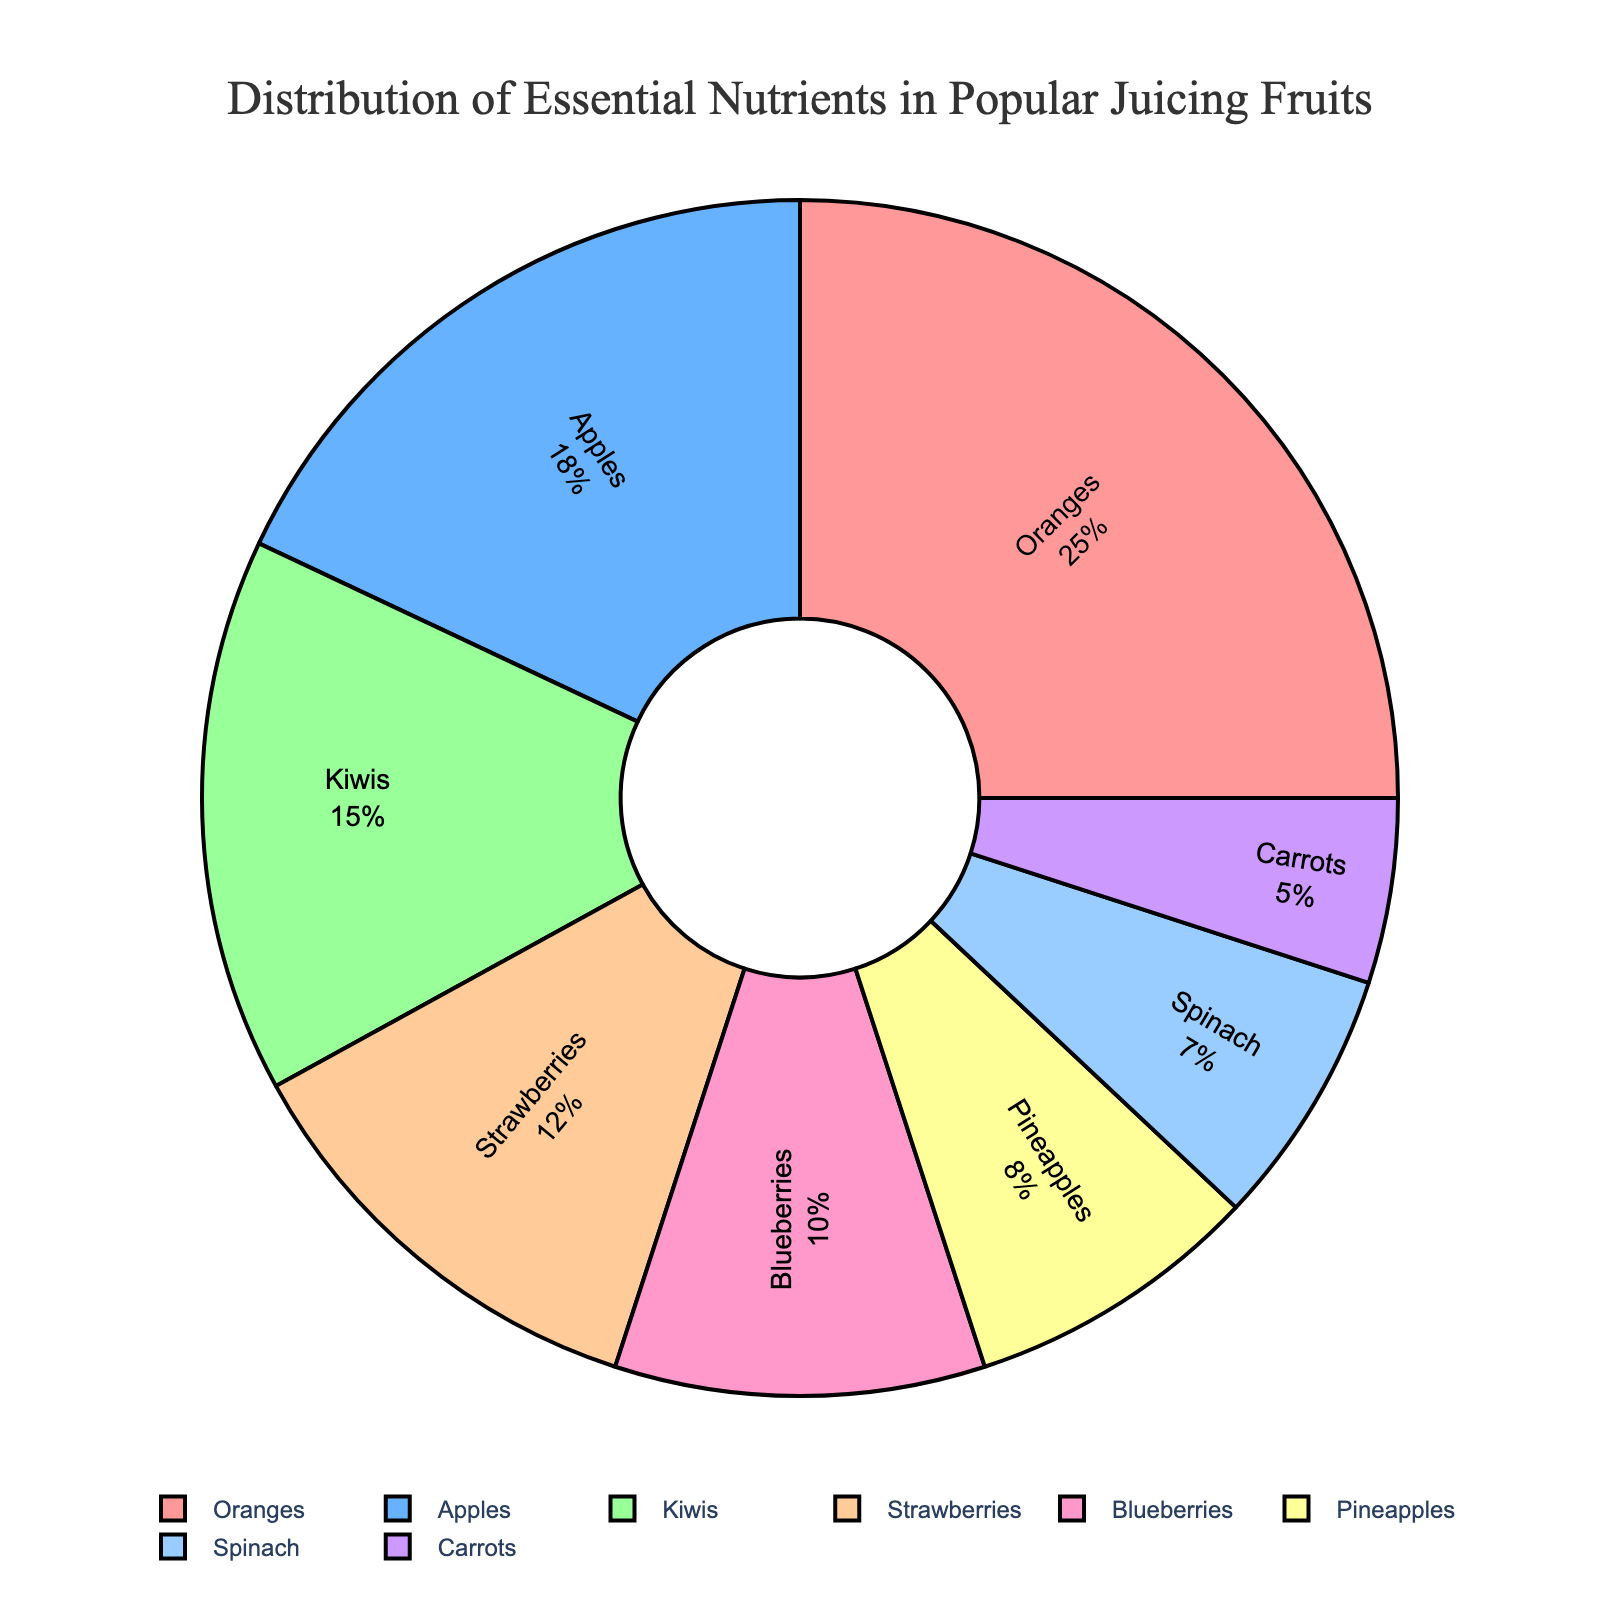What is the most nutrient-rich fruit for juicing? The pie chart shows that oranges have the largest percentage of essential nutrients at 25%.
Answer: Oranges Which fruit contributes the least to the essential nutrient distribution in juicing? Carrots have the smallest segment in the pie chart, indicating they contribute only 5% to the essential nutrient distribution.
Answer: Carrots How does the nutrient percentage of strawberries compare to that of kiwis? The pie chart indicates that strawberries have 12% and kiwis have 15%. Therefore, kiwis have a higher nutrient percentage by 3%.
Answer: Kiwis have 3% more What is the cumulative nutrient percentage of apples and blueberries? According to the pie chart, apples contribute 18% and blueberries contribute 10%. Summing these up gives 28%.
Answer: 28% By how much does the nutrient percentage of oranges exceed that of pineapples? Oranges contribute 25% while pineapples contribute 8%. The difference between these percentages is 25% - 8% = 17%.
Answer: 17% What fraction of the essential nutrients in juicing fruits is provided by spinach and carrots combined? Spinach provides 7% and carrots provide 5%. Combining these gives 7% + 5% = 12%.
Answer: 12% Which group of fruits (oranges and apples) or (kiwis and strawberries) has a higher combined nutrient percentage? Oranges and apples combined give 25% + 18% = 43%. Kiwis and strawberries combined give 15% + 12% = 27%. Therefore, oranges and apples have a higher combined nutrient percentage.
Answer: Oranges and apples If pineapples, spinach, and carrots are grouped together, what percentage of essential nutrients does this group provide? Pineapples provide 8%, spinach provides 7%, and carrots provide 5%. Summing these percentages gives 8% + 7% + 5% = 20%.
Answer: 20% Which color represents the fruit with the second smallest nutrient percentage? The pie chart shows that carrots have the smallest percentage at 5%, followed by spinach with 7%, which is represented by a color that might be light blue or similar.
Answer: Spinach (Light Blue) 